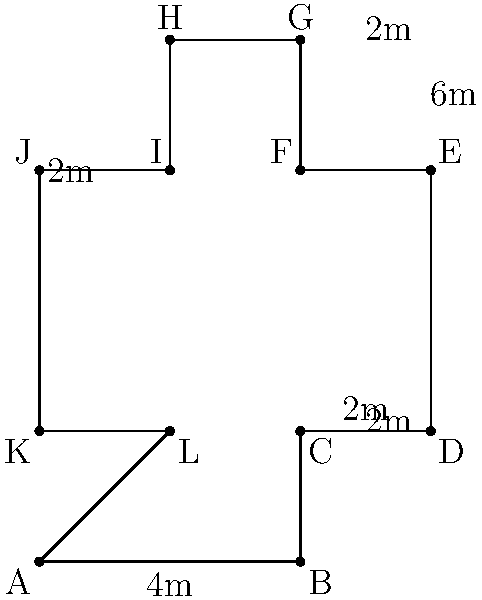In our parish, we're planning to create a cross-shaped prayer garden. The dimensions are shown in the diagram above. What is the perimeter of this sacred space, and how might this shape remind us of our Lord's sacrifice? Let's calculate the perimeter step-by-step, remembering that each side of the cross contributes to our spiritual journey:

1) Start at point A and move clockwise:
   AB = 4m
   BC = 2m
   CD = 2m
   DE = 4m
   EF = 2m
   FG = 2m
   GH = 2m
   HI = 2m
   IJ = 2m
   JK = 4m
   KL = 2m
   LA = 2m

2) Sum up all these lengths:
   $$ 4 + 2 + 2 + 4 + 2 + 2 + 2 + 2 + 2 + 4 + 2 + 2 = 30 $$

3) The total perimeter is 30 meters.

This cross shape reminds us of our Lord's sacrifice on Calvary. As we walk around this garden, each step can be a meditation on Christ's love for us. The four extending arms of the cross can represent the four Gospels spreading the Good News to the four corners of the world.
Answer: 30 meters 